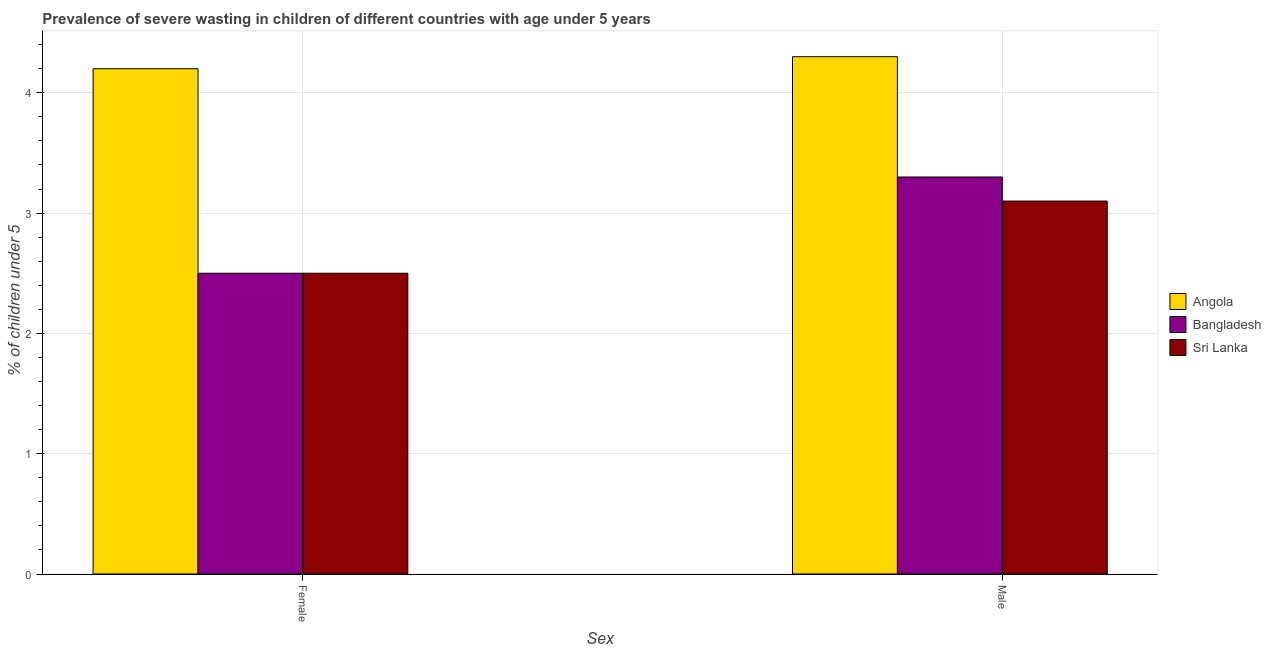How many groups of bars are there?
Offer a very short reply. 2. Are the number of bars per tick equal to the number of legend labels?
Your answer should be compact. Yes. Are the number of bars on each tick of the X-axis equal?
Keep it short and to the point. Yes. How many bars are there on the 1st tick from the left?
Give a very brief answer. 3. What is the label of the 2nd group of bars from the left?
Ensure brevity in your answer.  Male. What is the percentage of undernourished female children in Sri Lanka?
Keep it short and to the point. 2.5. Across all countries, what is the maximum percentage of undernourished female children?
Your answer should be compact. 4.2. Across all countries, what is the minimum percentage of undernourished female children?
Offer a terse response. 2.5. In which country was the percentage of undernourished male children maximum?
Your answer should be compact. Angola. In which country was the percentage of undernourished male children minimum?
Ensure brevity in your answer.  Sri Lanka. What is the total percentage of undernourished female children in the graph?
Your response must be concise. 9.2. What is the difference between the percentage of undernourished female children in Bangladesh and that in Sri Lanka?
Provide a short and direct response. 0. What is the difference between the percentage of undernourished male children in Bangladesh and the percentage of undernourished female children in Sri Lanka?
Your answer should be very brief. 0.8. What is the average percentage of undernourished female children per country?
Offer a very short reply. 3.07. What is the difference between the percentage of undernourished female children and percentage of undernourished male children in Sri Lanka?
Provide a short and direct response. -0.6. What is the ratio of the percentage of undernourished male children in Bangladesh to that in Angola?
Your answer should be very brief. 0.77. Is the percentage of undernourished female children in Sri Lanka less than that in Angola?
Offer a very short reply. Yes. What does the 1st bar from the left in Male represents?
Provide a short and direct response. Angola. What does the 3rd bar from the right in Female represents?
Make the answer very short. Angola. How many bars are there?
Offer a terse response. 6. Are all the bars in the graph horizontal?
Your response must be concise. No. How many countries are there in the graph?
Provide a short and direct response. 3. Are the values on the major ticks of Y-axis written in scientific E-notation?
Offer a terse response. No. Does the graph contain grids?
Your response must be concise. Yes. Where does the legend appear in the graph?
Your response must be concise. Center right. How many legend labels are there?
Keep it short and to the point. 3. How are the legend labels stacked?
Ensure brevity in your answer.  Vertical. What is the title of the graph?
Your answer should be very brief. Prevalence of severe wasting in children of different countries with age under 5 years. What is the label or title of the X-axis?
Provide a short and direct response. Sex. What is the label or title of the Y-axis?
Give a very brief answer.  % of children under 5. What is the  % of children under 5 in Angola in Female?
Make the answer very short. 4.2. What is the  % of children under 5 of Bangladesh in Female?
Ensure brevity in your answer.  2.5. What is the  % of children under 5 in Sri Lanka in Female?
Ensure brevity in your answer.  2.5. What is the  % of children under 5 of Angola in Male?
Make the answer very short. 4.3. What is the  % of children under 5 in Bangladesh in Male?
Provide a short and direct response. 3.3. What is the  % of children under 5 in Sri Lanka in Male?
Offer a very short reply. 3.1. Across all Sex, what is the maximum  % of children under 5 of Angola?
Your response must be concise. 4.3. Across all Sex, what is the maximum  % of children under 5 of Bangladesh?
Offer a terse response. 3.3. Across all Sex, what is the maximum  % of children under 5 in Sri Lanka?
Make the answer very short. 3.1. Across all Sex, what is the minimum  % of children under 5 of Angola?
Keep it short and to the point. 4.2. Across all Sex, what is the minimum  % of children under 5 in Sri Lanka?
Ensure brevity in your answer.  2.5. What is the total  % of children under 5 of Angola in the graph?
Your answer should be compact. 8.5. What is the total  % of children under 5 of Bangladesh in the graph?
Offer a very short reply. 5.8. What is the difference between the  % of children under 5 in Angola in Female and that in Male?
Your answer should be very brief. -0.1. What is the difference between the  % of children under 5 in Angola in Female and the  % of children under 5 in Bangladesh in Male?
Give a very brief answer. 0.9. What is the difference between the  % of children under 5 of Angola in Female and the  % of children under 5 of Sri Lanka in Male?
Keep it short and to the point. 1.1. What is the average  % of children under 5 in Angola per Sex?
Your answer should be compact. 4.25. What is the average  % of children under 5 of Bangladesh per Sex?
Keep it short and to the point. 2.9. What is the average  % of children under 5 in Sri Lanka per Sex?
Your response must be concise. 2.8. What is the difference between the  % of children under 5 in Angola and  % of children under 5 in Sri Lanka in Female?
Provide a succinct answer. 1.7. What is the difference between the  % of children under 5 in Bangladesh and  % of children under 5 in Sri Lanka in Female?
Offer a very short reply. 0. What is the difference between the  % of children under 5 in Angola and  % of children under 5 in Bangladesh in Male?
Ensure brevity in your answer.  1. What is the difference between the  % of children under 5 in Bangladesh and  % of children under 5 in Sri Lanka in Male?
Ensure brevity in your answer.  0.2. What is the ratio of the  % of children under 5 of Angola in Female to that in Male?
Your answer should be very brief. 0.98. What is the ratio of the  % of children under 5 in Bangladesh in Female to that in Male?
Your answer should be compact. 0.76. What is the ratio of the  % of children under 5 in Sri Lanka in Female to that in Male?
Make the answer very short. 0.81. What is the difference between the highest and the lowest  % of children under 5 of Bangladesh?
Ensure brevity in your answer.  0.8. What is the difference between the highest and the lowest  % of children under 5 in Sri Lanka?
Ensure brevity in your answer.  0.6. 